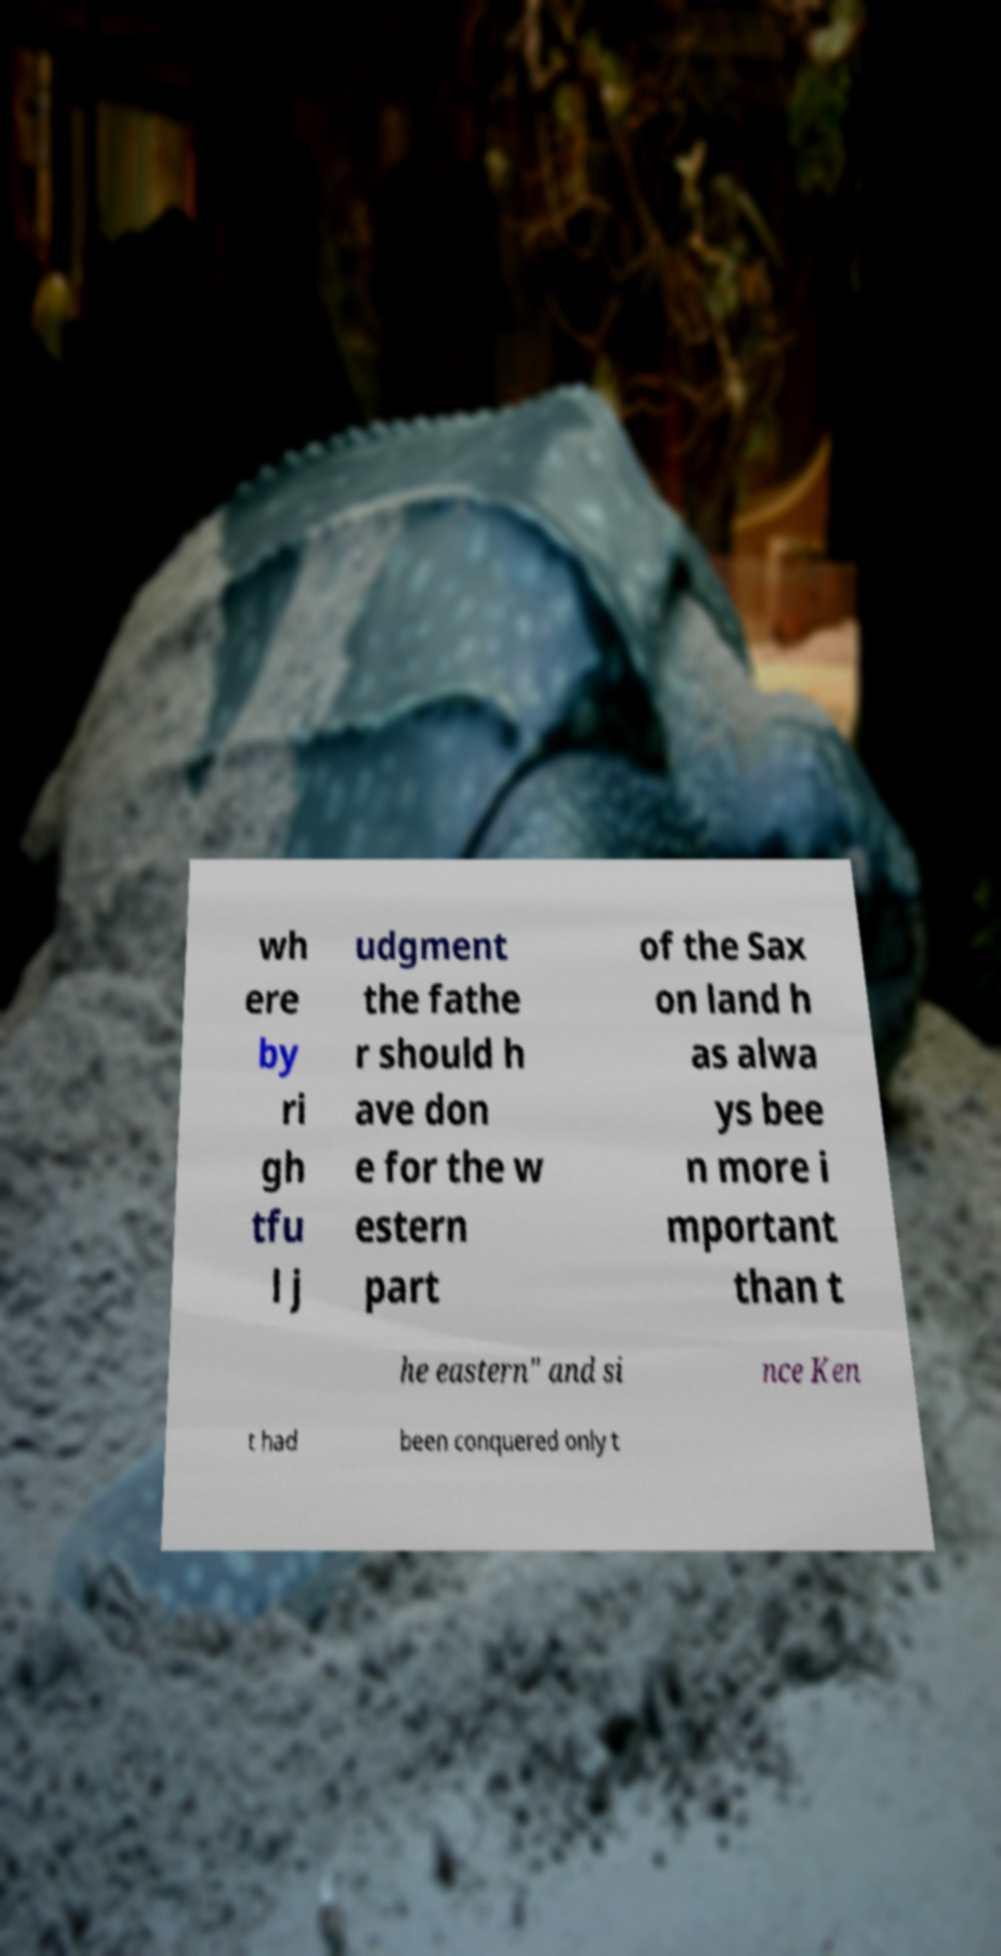Can you read and provide the text displayed in the image?This photo seems to have some interesting text. Can you extract and type it out for me? wh ere by ri gh tfu l j udgment the fathe r should h ave don e for the w estern part of the Sax on land h as alwa ys bee n more i mportant than t he eastern" and si nce Ken t had been conquered only t 